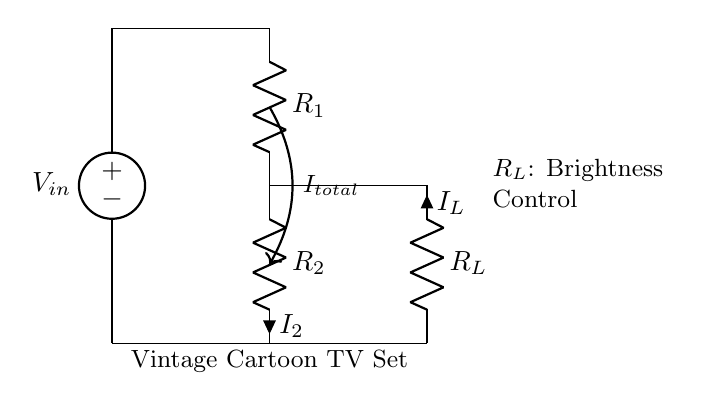What is the total current in the circuit? The total current is indicated by the label pointing to the current between the two resistors. The arrow shows that this current, represented as I total, is the sum of the currents flowing through resistors R1 and R2.
Answer: I total What components are present in this circuit? The circuit contains a voltage source, two resistors (R1 and R2), and a load resistor (R_L). These components are labeled accordingly in the diagram, making it easy to identify them.
Answer: Voltage source, R1, R2, R_L What is the role of the load resistor? The load resistor (R_L) is labeled as the brightness control for the vintage cartoon TV set. This means it affects the brightness of the TV by varying the current flowing through it based on its resistance.
Answer: Brightness control Which resistor has the current labeled as I2? The current labeled as I2 is flowing through resistor R2. The diagram shows this current flowing into the bottom of R2, distinctly indicating the direction and relationship of the current to the component.
Answer: R2 How does the current divider affect R_L? The current divider principle states that the total current is divided between the resistors in parallel. If R_L has a specific resistance value, the current flowing through it will be inversely proportional to its resistance, while also depending on R1 and R2's values. Thus, adjusting R_L will change the brightness based on its resistance.
Answer: Adjusts brightness What can you say about the configuration of R1 and R2? R1 and R2 are connected in parallel, sharing the same voltage across them from the voltage source. The configuration allows for a current division where the total current splits based on each resistor's value.
Answer: Parallel configuration 